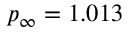<formula> <loc_0><loc_0><loc_500><loc_500>p _ { \infty } = 1 . 0 1 3</formula> 